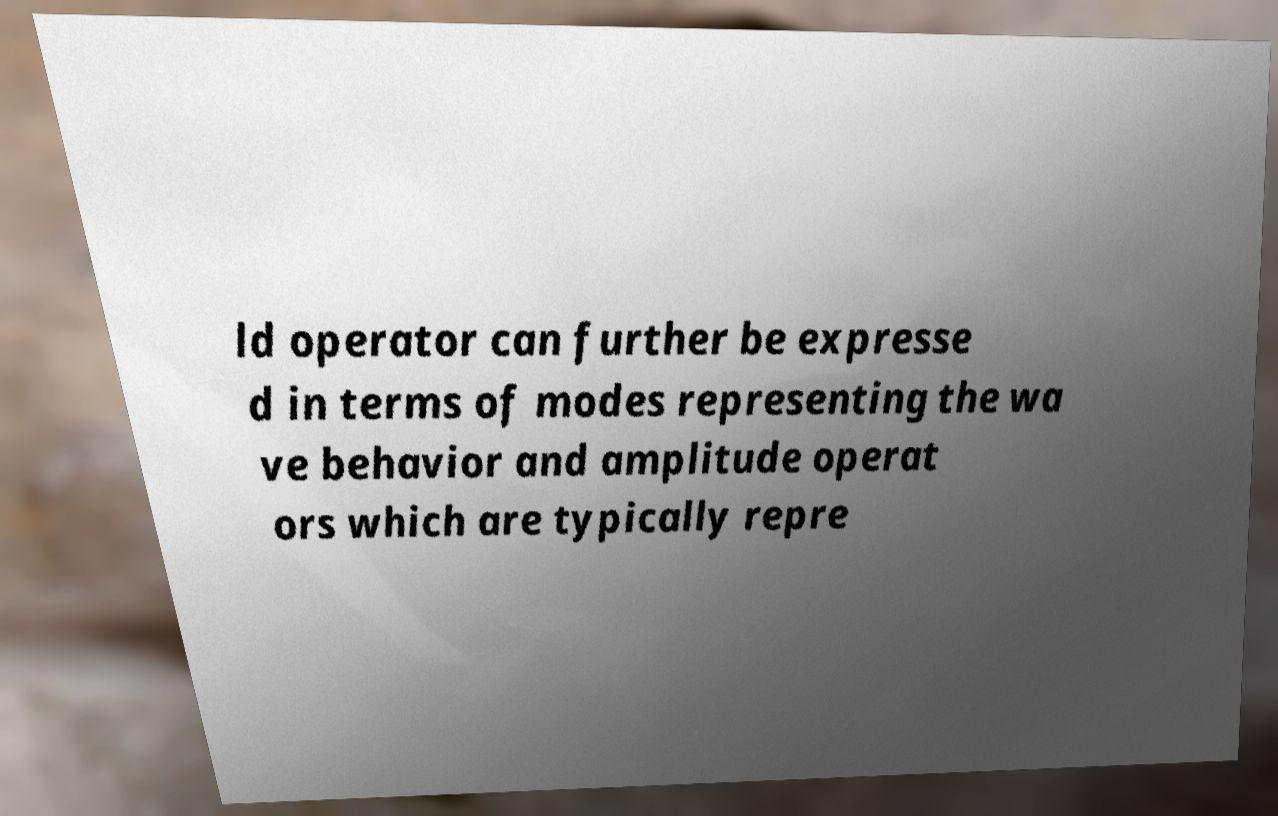Please read and relay the text visible in this image. What does it say? ld operator can further be expresse d in terms of modes representing the wa ve behavior and amplitude operat ors which are typically repre 